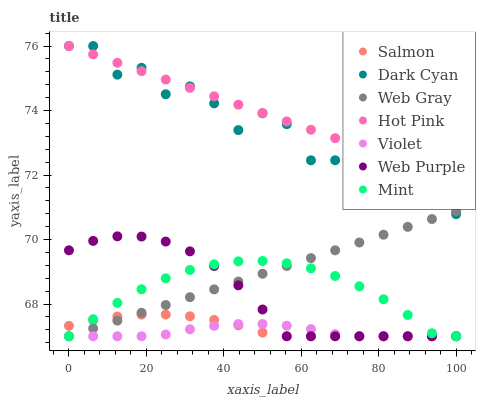Does Violet have the minimum area under the curve?
Answer yes or no. Yes. Does Hot Pink have the maximum area under the curve?
Answer yes or no. Yes. Does Salmon have the minimum area under the curve?
Answer yes or no. No. Does Salmon have the maximum area under the curve?
Answer yes or no. No. Is Web Gray the smoothest?
Answer yes or no. Yes. Is Dark Cyan the roughest?
Answer yes or no. Yes. Is Hot Pink the smoothest?
Answer yes or no. No. Is Hot Pink the roughest?
Answer yes or no. No. Does Web Gray have the lowest value?
Answer yes or no. Yes. Does Hot Pink have the lowest value?
Answer yes or no. No. Does Dark Cyan have the highest value?
Answer yes or no. Yes. Does Salmon have the highest value?
Answer yes or no. No. Is Violet less than Dark Cyan?
Answer yes or no. Yes. Is Hot Pink greater than Mint?
Answer yes or no. Yes. Does Violet intersect Mint?
Answer yes or no. Yes. Is Violet less than Mint?
Answer yes or no. No. Is Violet greater than Mint?
Answer yes or no. No. Does Violet intersect Dark Cyan?
Answer yes or no. No. 